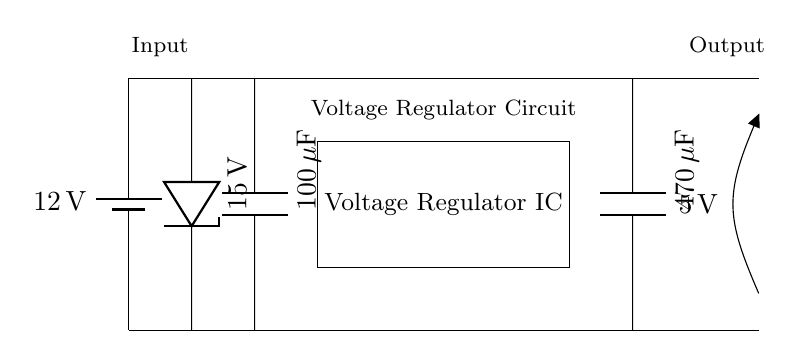What is the input voltage of the circuit? The input voltage is specified on the battery symbol in the circuit as 12 volts.
Answer: 12 volts What type of component is represented by the rectangle in the circuit? The rectangle represents a voltage regulator IC, which is a component used to maintain a stable output voltage regardless of variations in input voltage or load conditions.
Answer: Voltage Regulator IC What is the value of the output capacitor? The output capacitor is labeled in the circuit diagram as having a value of 470 microfarads.
Answer: 470 microfarads What is the purpose of the Zener diode in this circuit? The Zener diode is used for overvoltage protection by allowing excess voltage to bypass to ground, hence preventing damage to downstream components.
Answer: Overvoltage protection What is the output voltage maintained by the regulator? The output voltage is shown as 5 volts on the circuit, indicating the voltage supplied to the load.
Answer: 5 volts What is the role of the input capacitor? The input capacitor smooths fluctuations in the input voltage, helping to stabilize the input to the voltage regulator IC before voltage regulation occurs.
Answer: Stabilization Why is the voltage regulator necessary in a vehicle's electrical system? The voltage regulator is necessary to ensure that the electronic components within the vehicle receive a consistent voltage, which is essential for proper functionality of sensitive electronics.
Answer: Consistent voltage 